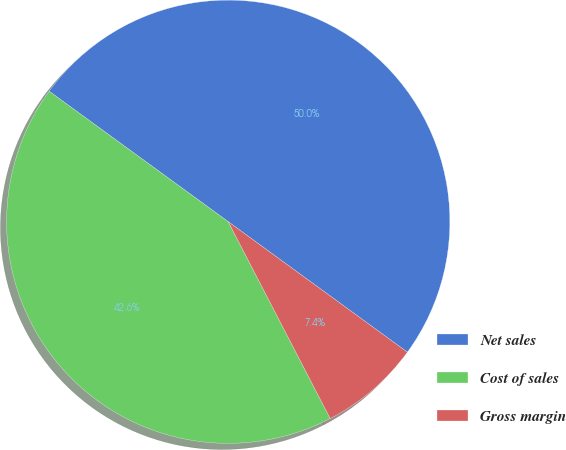Convert chart. <chart><loc_0><loc_0><loc_500><loc_500><pie_chart><fcel>Net sales<fcel>Cost of sales<fcel>Gross margin<nl><fcel>50.0%<fcel>42.63%<fcel>7.37%<nl></chart> 